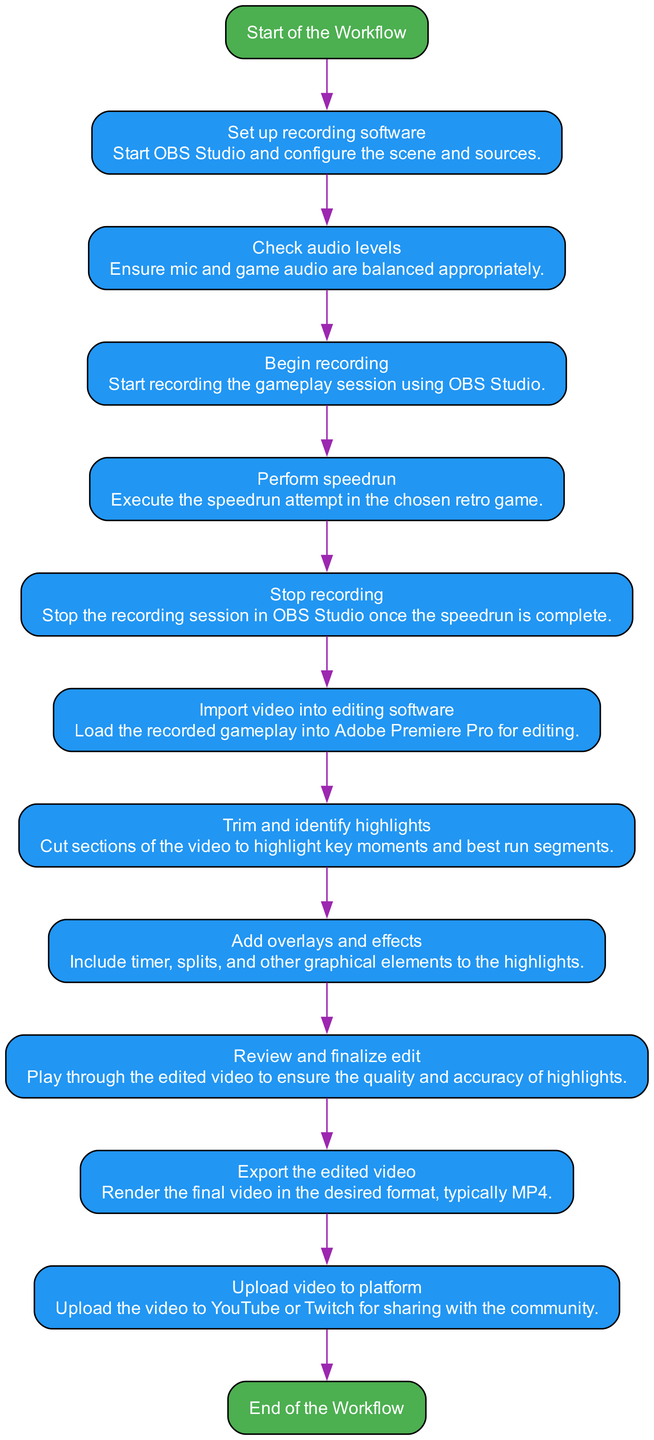What is the first step in the workflow? The first step in the workflow is "Start of the Workflow," represented as a starting node in the diagram.
Answer: Start of the Workflow How many process nodes are in the diagram? By counting each node with the type "process" in the diagram, we find there are 9 process nodes.
Answer: 9 What comes after "Check audio levels"? The node that follows "Check audio levels" in the diagram is "Begin recording."
Answer: Begin recording What is the last step in the workflow? The last step in the workflow is "End of the Workflow," which is represented as an end node in the diagram.
Answer: End of the Workflow What are the details associated with the "Trim and identify highlights" process? The details provided in the diagram for this process describe it as "Cut sections of the video to highlight key moments and best run segments."
Answer: Cut sections of the video to highlight key moments and best run segments Which two nodes are connected directly by an edge after "Perform speedrun"? The node connected directly after "Perform speedrun" is "Stop recording."
Answer: Stop recording How does the workflow progress from recording to editing? The workflow moves from "Stop recording" to "Import video into editing software," indicating that recording and editing are sequential processes.
Answer: Import video into editing software What color represents the process nodes in the diagram? Process nodes in the diagram are filled with the color blue, which distinguishes them from the start and end nodes.
Answer: Blue What is the purpose of the "Add overlays and effects" step? The step is aimed at enhancing the video's visual appeal by including elements like a timer, splits, and other graphical enhancements.
Answer: Include timer, splits, and other graphical elements to the highlights 